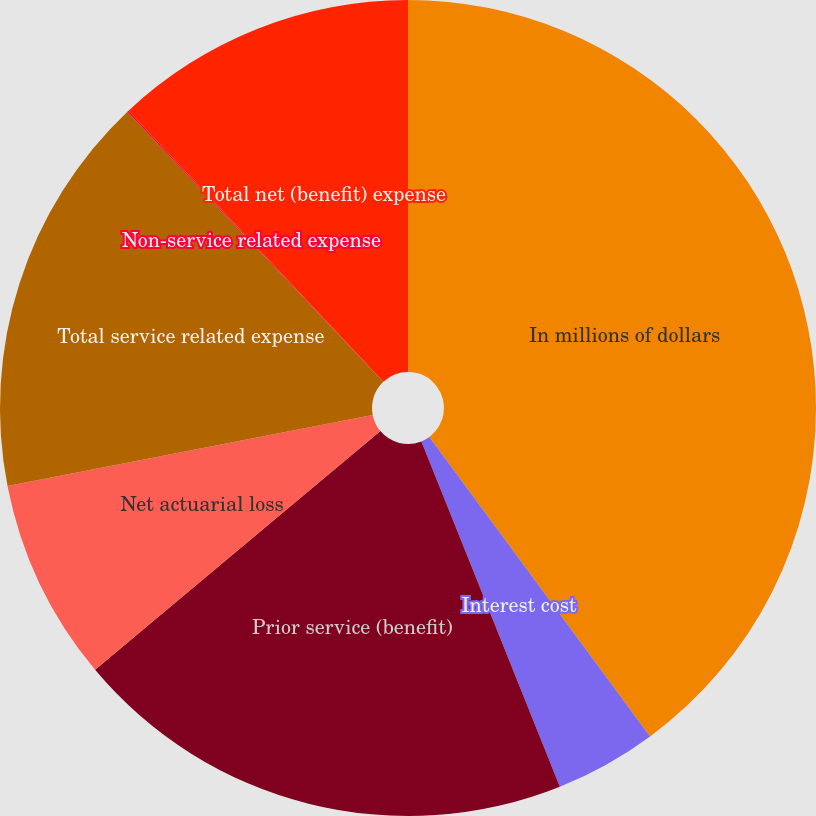<chart> <loc_0><loc_0><loc_500><loc_500><pie_chart><fcel>In millions of dollars<fcel>Interest cost<fcel>Prior service (benefit)<fcel>Net actuarial loss<fcel>Total service related expense<fcel>Non-service related expense<fcel>Total net (benefit) expense<nl><fcel>39.89%<fcel>4.04%<fcel>19.98%<fcel>8.03%<fcel>15.99%<fcel>0.06%<fcel>12.01%<nl></chart> 